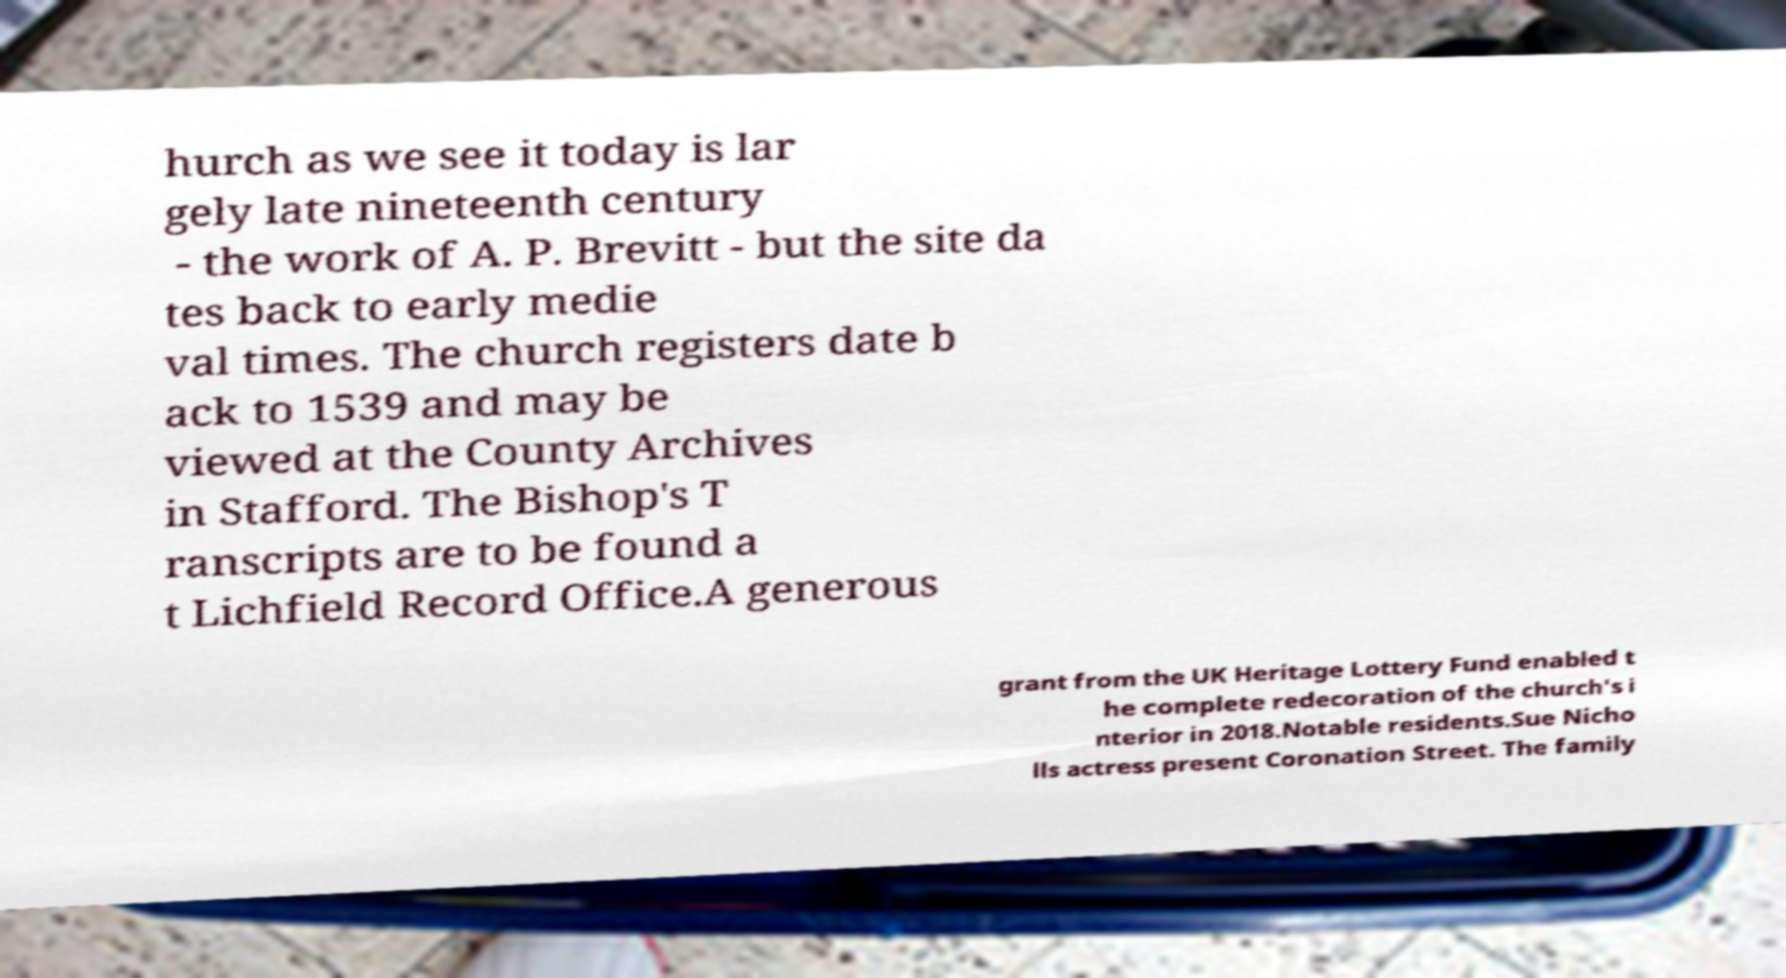Please read and relay the text visible in this image. What does it say? hurch as we see it today is lar gely late nineteenth century - the work of A. P. Brevitt - but the site da tes back to early medie val times. The church registers date b ack to 1539 and may be viewed at the County Archives in Stafford. The Bishop's T ranscripts are to be found a t Lichfield Record Office.A generous grant from the UK Heritage Lottery Fund enabled t he complete redecoration of the church's i nterior in 2018.Notable residents.Sue Nicho lls actress present Coronation Street. The family 